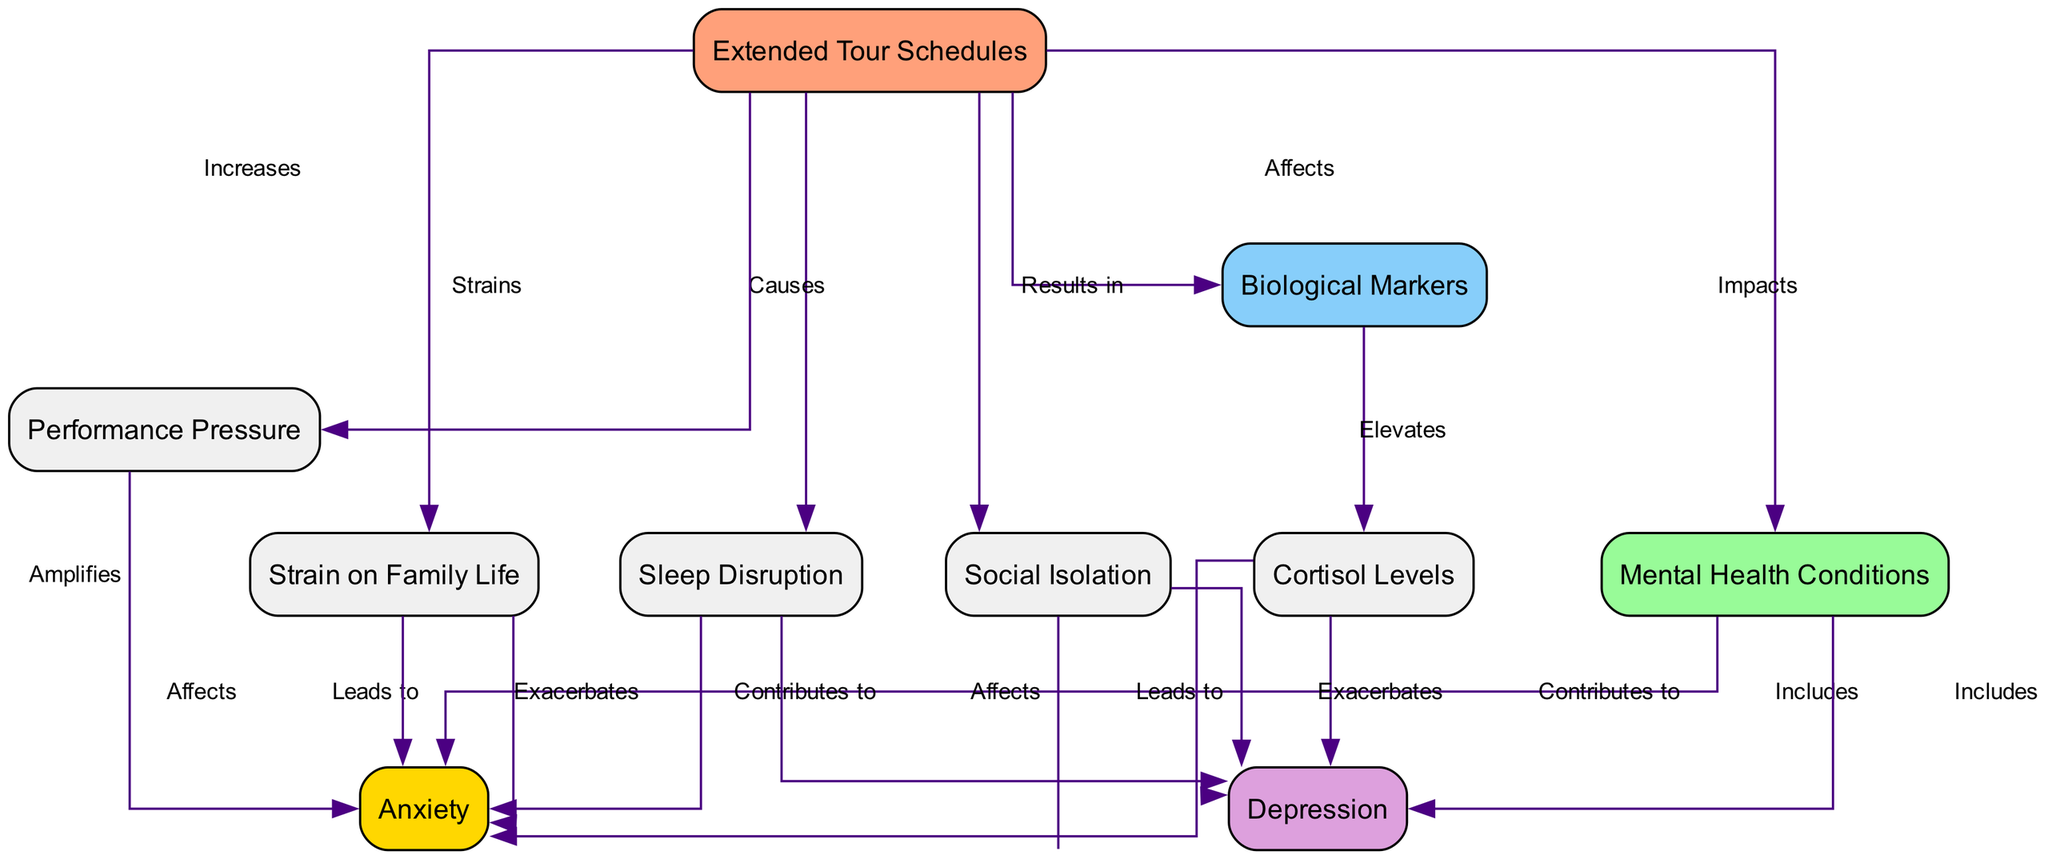What is the main effect of extended tour schedules? The diagram indicates that extended tour schedules impact mental health conditions. This is directly depicted by the edge that connects the "Tour_Schedule" node to the "Mental_Health" node, labeled "Impacts."
Answer: Impacts mental health conditions How many mental health conditions are included in the diagram? The diagram shows two mental health conditions, which are represented by the "Anxiety" and "Depression" nodes that connect to the "Mental_Health" node.
Answer: Two Which biological marker is elevated due to extended tour schedules? The diagram shows that extended tour schedules affect biological markers, which in turn elevates cortisol levels as indicated by the edge connecting "Biological_Markers" to "Cortisol_Levels," labeled "Elevates."
Answer: Cortisol levels How does sleep disruption affect anxiety? According to the diagram, sleep disruption leads to anxiety. This is shown by the edge connecting "Sleep_Disruption" to "Anxiety," marked with the label "Leads to."
Answer: Leads to What factors contribute to anxiety from extended tour schedules? The diagram indicates multiple factors: cortisol levels, sleep disruption, social isolation, performance pressure, and strain on family life, all contributing to anxiety through their respective relationships within the diagram. Thus, a collective understanding of multiple elements is needed to answer this question.
Answer: Cortisol levels, sleep disruption, social isolation, performance pressure, strain on family life What does social isolation exacerbate according to the diagram? The diagram illustrates that social isolation exacerbates both anxiety and depression, demonstrated by the connections from the "Social_Isolation" node to the respective mental health condition nodes, both labeled "Exacerbates."
Answer: Anxiety and depression How does performance pressure amplify anxiety? Performance pressure increases anxiety through its relationship in the diagram, where "Performance_Pressure" connects to "Anxiety," and is marked with the edge labeled "Amplifies." This shows the direct cause-and-effect relationship within the context of the diagram.
Answer: Amplifies What is the relationship labeled between touring and strain on family life? The diagram specifies that extended tour schedules strain family life, indicated by the edge between "Tour_Schedule" and "Strain on Family Life," showing the negative impact of touring on family dynamics.
Answer: Strains How does extended touring impact sleep? The diagram clearly states that extended tour schedules cause sleep disruption, as depicted by the edge connecting "Tour_Schedule" to "Sleep_Disruption," labeled "Causes." This illustrates a direct relationship where one element negatively influences the other.
Answer: Causes 